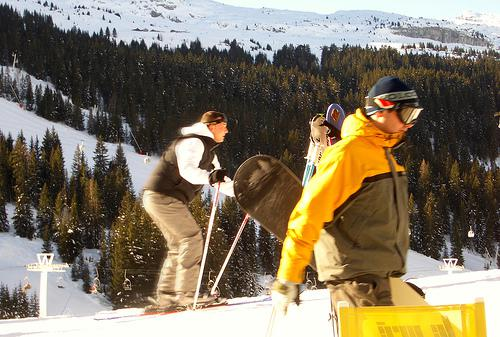Question: why are these people engaging in these activities?
Choices:
A. They are bored.
B. Recreation.
C. It is fun.
D. To practice their skills.
Answer with the letter. Answer: B Question: what activity are these people doing?
Choices:
A. Skiing.
B. Eating.
C. Talking.
D. Running.
Answer with the letter. Answer: A Question: where are these people?
Choices:
A. In a house.
B. Mountains.
C. In a park.
D. In a theater.
Answer with the letter. Answer: B Question: who is engaging in these activities?
Choices:
A. Men.
B. Children.
C. Teachers.
D. Nurses.
Answer with the letter. Answer: A Question: what is the color of the first man's coat?
Choices:
A. Black.
B. Red and blue.
C. Green, yellow, and white.
D. Grey and yellow.
Answer with the letter. Answer: D 